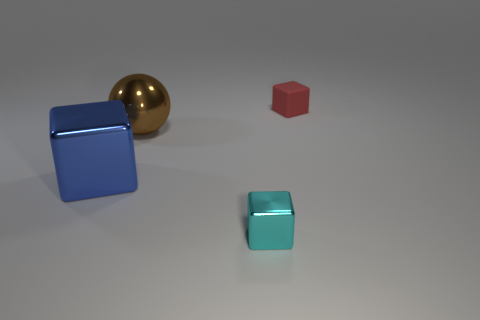Is there any other thing that is the same material as the small red object?
Provide a succinct answer. No. How many tiny metal objects have the same shape as the small rubber thing?
Your answer should be very brief. 1. There is a blue cube that is the same size as the brown sphere; what material is it?
Your answer should be very brief. Metal. Are there any blue things that have the same material as the big brown object?
Your answer should be very brief. Yes. Are there fewer large things right of the large metallic ball than small matte cubes?
Your response must be concise. Yes. There is a tiny block that is on the right side of the small block that is in front of the small matte thing; what is it made of?
Give a very brief answer. Rubber. There is a thing that is behind the blue object and in front of the tiny red cube; what shape is it?
Your response must be concise. Sphere. How many other things are the same color as the shiny sphere?
Make the answer very short. 0. What number of objects are either things behind the cyan thing or shiny things?
Offer a terse response. 4. How big is the shiny block right of the metallic object that is behind the large block?
Your response must be concise. Small. 